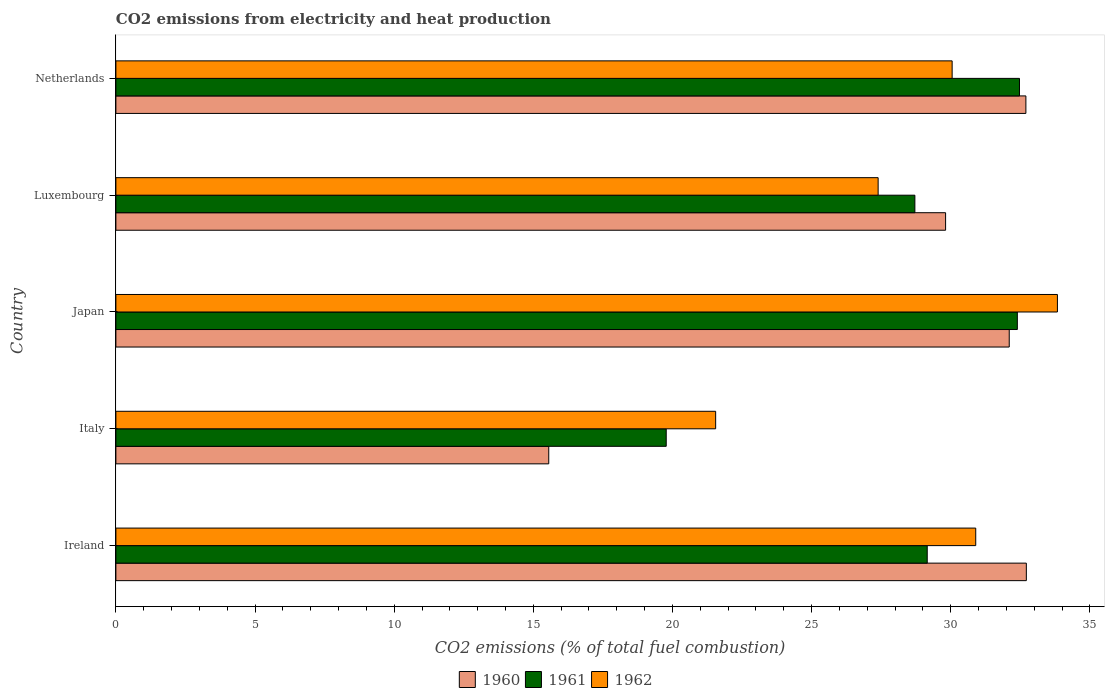How many different coloured bars are there?
Offer a very short reply. 3. Are the number of bars per tick equal to the number of legend labels?
Ensure brevity in your answer.  Yes. Are the number of bars on each tick of the Y-axis equal?
Your response must be concise. Yes. What is the label of the 2nd group of bars from the top?
Your response must be concise. Luxembourg. What is the amount of CO2 emitted in 1960 in Italy?
Offer a terse response. 15.55. Across all countries, what is the maximum amount of CO2 emitted in 1960?
Provide a succinct answer. 32.72. Across all countries, what is the minimum amount of CO2 emitted in 1961?
Offer a very short reply. 19.78. What is the total amount of CO2 emitted in 1961 in the graph?
Your answer should be compact. 142.5. What is the difference between the amount of CO2 emitted in 1962 in Ireland and that in Luxembourg?
Your response must be concise. 3.51. What is the difference between the amount of CO2 emitted in 1960 in Netherlands and the amount of CO2 emitted in 1961 in Ireland?
Keep it short and to the point. 3.55. What is the average amount of CO2 emitted in 1961 per country?
Provide a succinct answer. 28.5. What is the difference between the amount of CO2 emitted in 1962 and amount of CO2 emitted in 1960 in Netherlands?
Provide a short and direct response. -2.65. In how many countries, is the amount of CO2 emitted in 1961 greater than 2 %?
Provide a succinct answer. 5. What is the ratio of the amount of CO2 emitted in 1962 in Ireland to that in Luxembourg?
Ensure brevity in your answer.  1.13. What is the difference between the highest and the second highest amount of CO2 emitted in 1960?
Your answer should be compact. 0.02. What is the difference between the highest and the lowest amount of CO2 emitted in 1962?
Your answer should be compact. 12.28. In how many countries, is the amount of CO2 emitted in 1960 greater than the average amount of CO2 emitted in 1960 taken over all countries?
Your answer should be compact. 4. What does the 3rd bar from the bottom in Italy represents?
Your answer should be compact. 1962. Is it the case that in every country, the sum of the amount of CO2 emitted in 1962 and amount of CO2 emitted in 1960 is greater than the amount of CO2 emitted in 1961?
Give a very brief answer. Yes. How many countries are there in the graph?
Keep it short and to the point. 5. What is the difference between two consecutive major ticks on the X-axis?
Your answer should be very brief. 5. Are the values on the major ticks of X-axis written in scientific E-notation?
Your answer should be very brief. No. Does the graph contain any zero values?
Ensure brevity in your answer.  No. Where does the legend appear in the graph?
Your answer should be compact. Bottom center. How are the legend labels stacked?
Your answer should be very brief. Horizontal. What is the title of the graph?
Ensure brevity in your answer.  CO2 emissions from electricity and heat production. What is the label or title of the X-axis?
Provide a short and direct response. CO2 emissions (% of total fuel combustion). What is the CO2 emissions (% of total fuel combustion) of 1960 in Ireland?
Keep it short and to the point. 32.72. What is the CO2 emissions (% of total fuel combustion) in 1961 in Ireland?
Your response must be concise. 29.15. What is the CO2 emissions (% of total fuel combustion) of 1962 in Ireland?
Provide a short and direct response. 30.9. What is the CO2 emissions (% of total fuel combustion) in 1960 in Italy?
Your answer should be very brief. 15.55. What is the CO2 emissions (% of total fuel combustion) of 1961 in Italy?
Your response must be concise. 19.78. What is the CO2 emissions (% of total fuel combustion) in 1962 in Italy?
Give a very brief answer. 21.55. What is the CO2 emissions (% of total fuel combustion) of 1960 in Japan?
Give a very brief answer. 32.1. What is the CO2 emissions (% of total fuel combustion) of 1961 in Japan?
Keep it short and to the point. 32.39. What is the CO2 emissions (% of total fuel combustion) of 1962 in Japan?
Keep it short and to the point. 33.83. What is the CO2 emissions (% of total fuel combustion) of 1960 in Luxembourg?
Your answer should be compact. 29.81. What is the CO2 emissions (% of total fuel combustion) in 1961 in Luxembourg?
Make the answer very short. 28.71. What is the CO2 emissions (% of total fuel combustion) in 1962 in Luxembourg?
Offer a terse response. 27.39. What is the CO2 emissions (% of total fuel combustion) in 1960 in Netherlands?
Your answer should be very brief. 32.7. What is the CO2 emissions (% of total fuel combustion) in 1961 in Netherlands?
Keep it short and to the point. 32.47. What is the CO2 emissions (% of total fuel combustion) in 1962 in Netherlands?
Your answer should be very brief. 30.05. Across all countries, what is the maximum CO2 emissions (% of total fuel combustion) of 1960?
Keep it short and to the point. 32.72. Across all countries, what is the maximum CO2 emissions (% of total fuel combustion) in 1961?
Provide a succinct answer. 32.47. Across all countries, what is the maximum CO2 emissions (% of total fuel combustion) of 1962?
Offer a very short reply. 33.83. Across all countries, what is the minimum CO2 emissions (% of total fuel combustion) in 1960?
Keep it short and to the point. 15.55. Across all countries, what is the minimum CO2 emissions (% of total fuel combustion) in 1961?
Offer a very short reply. 19.78. Across all countries, what is the minimum CO2 emissions (% of total fuel combustion) in 1962?
Keep it short and to the point. 21.55. What is the total CO2 emissions (% of total fuel combustion) in 1960 in the graph?
Provide a short and direct response. 142.89. What is the total CO2 emissions (% of total fuel combustion) in 1961 in the graph?
Your answer should be compact. 142.5. What is the total CO2 emissions (% of total fuel combustion) of 1962 in the graph?
Provide a short and direct response. 143.72. What is the difference between the CO2 emissions (% of total fuel combustion) in 1960 in Ireland and that in Italy?
Your answer should be very brief. 17.16. What is the difference between the CO2 emissions (% of total fuel combustion) of 1961 in Ireland and that in Italy?
Ensure brevity in your answer.  9.38. What is the difference between the CO2 emissions (% of total fuel combustion) in 1962 in Ireland and that in Italy?
Offer a very short reply. 9.35. What is the difference between the CO2 emissions (% of total fuel combustion) in 1960 in Ireland and that in Japan?
Ensure brevity in your answer.  0.61. What is the difference between the CO2 emissions (% of total fuel combustion) of 1961 in Ireland and that in Japan?
Keep it short and to the point. -3.24. What is the difference between the CO2 emissions (% of total fuel combustion) in 1962 in Ireland and that in Japan?
Make the answer very short. -2.94. What is the difference between the CO2 emissions (% of total fuel combustion) of 1960 in Ireland and that in Luxembourg?
Make the answer very short. 2.9. What is the difference between the CO2 emissions (% of total fuel combustion) in 1961 in Ireland and that in Luxembourg?
Make the answer very short. 0.44. What is the difference between the CO2 emissions (% of total fuel combustion) of 1962 in Ireland and that in Luxembourg?
Your answer should be compact. 3.51. What is the difference between the CO2 emissions (% of total fuel combustion) of 1960 in Ireland and that in Netherlands?
Offer a terse response. 0.02. What is the difference between the CO2 emissions (% of total fuel combustion) in 1961 in Ireland and that in Netherlands?
Your answer should be very brief. -3.31. What is the difference between the CO2 emissions (% of total fuel combustion) of 1962 in Ireland and that in Netherlands?
Your response must be concise. 0.85. What is the difference between the CO2 emissions (% of total fuel combustion) in 1960 in Italy and that in Japan?
Offer a very short reply. -16.55. What is the difference between the CO2 emissions (% of total fuel combustion) of 1961 in Italy and that in Japan?
Your answer should be compact. -12.62. What is the difference between the CO2 emissions (% of total fuel combustion) of 1962 in Italy and that in Japan?
Give a very brief answer. -12.28. What is the difference between the CO2 emissions (% of total fuel combustion) in 1960 in Italy and that in Luxembourg?
Offer a terse response. -14.26. What is the difference between the CO2 emissions (% of total fuel combustion) of 1961 in Italy and that in Luxembourg?
Your answer should be very brief. -8.93. What is the difference between the CO2 emissions (% of total fuel combustion) of 1962 in Italy and that in Luxembourg?
Provide a short and direct response. -5.84. What is the difference between the CO2 emissions (% of total fuel combustion) in 1960 in Italy and that in Netherlands?
Your answer should be very brief. -17.15. What is the difference between the CO2 emissions (% of total fuel combustion) in 1961 in Italy and that in Netherlands?
Give a very brief answer. -12.69. What is the difference between the CO2 emissions (% of total fuel combustion) of 1962 in Italy and that in Netherlands?
Provide a short and direct response. -8.5. What is the difference between the CO2 emissions (% of total fuel combustion) of 1960 in Japan and that in Luxembourg?
Provide a succinct answer. 2.29. What is the difference between the CO2 emissions (% of total fuel combustion) in 1961 in Japan and that in Luxembourg?
Provide a succinct answer. 3.68. What is the difference between the CO2 emissions (% of total fuel combustion) in 1962 in Japan and that in Luxembourg?
Offer a very short reply. 6.44. What is the difference between the CO2 emissions (% of total fuel combustion) of 1960 in Japan and that in Netherlands?
Offer a very short reply. -0.6. What is the difference between the CO2 emissions (% of total fuel combustion) in 1961 in Japan and that in Netherlands?
Your answer should be very brief. -0.08. What is the difference between the CO2 emissions (% of total fuel combustion) in 1962 in Japan and that in Netherlands?
Your response must be concise. 3.78. What is the difference between the CO2 emissions (% of total fuel combustion) in 1960 in Luxembourg and that in Netherlands?
Ensure brevity in your answer.  -2.89. What is the difference between the CO2 emissions (% of total fuel combustion) of 1961 in Luxembourg and that in Netherlands?
Your answer should be compact. -3.76. What is the difference between the CO2 emissions (% of total fuel combustion) in 1962 in Luxembourg and that in Netherlands?
Offer a terse response. -2.66. What is the difference between the CO2 emissions (% of total fuel combustion) of 1960 in Ireland and the CO2 emissions (% of total fuel combustion) of 1961 in Italy?
Your response must be concise. 12.94. What is the difference between the CO2 emissions (% of total fuel combustion) of 1960 in Ireland and the CO2 emissions (% of total fuel combustion) of 1962 in Italy?
Provide a succinct answer. 11.16. What is the difference between the CO2 emissions (% of total fuel combustion) of 1961 in Ireland and the CO2 emissions (% of total fuel combustion) of 1962 in Italy?
Your response must be concise. 7.6. What is the difference between the CO2 emissions (% of total fuel combustion) in 1960 in Ireland and the CO2 emissions (% of total fuel combustion) in 1961 in Japan?
Make the answer very short. 0.32. What is the difference between the CO2 emissions (% of total fuel combustion) of 1960 in Ireland and the CO2 emissions (% of total fuel combustion) of 1962 in Japan?
Keep it short and to the point. -1.12. What is the difference between the CO2 emissions (% of total fuel combustion) of 1961 in Ireland and the CO2 emissions (% of total fuel combustion) of 1962 in Japan?
Give a very brief answer. -4.68. What is the difference between the CO2 emissions (% of total fuel combustion) in 1960 in Ireland and the CO2 emissions (% of total fuel combustion) in 1961 in Luxembourg?
Provide a short and direct response. 4.01. What is the difference between the CO2 emissions (% of total fuel combustion) in 1960 in Ireland and the CO2 emissions (% of total fuel combustion) in 1962 in Luxembourg?
Give a very brief answer. 5.33. What is the difference between the CO2 emissions (% of total fuel combustion) of 1961 in Ireland and the CO2 emissions (% of total fuel combustion) of 1962 in Luxembourg?
Make the answer very short. 1.76. What is the difference between the CO2 emissions (% of total fuel combustion) of 1960 in Ireland and the CO2 emissions (% of total fuel combustion) of 1961 in Netherlands?
Provide a succinct answer. 0.25. What is the difference between the CO2 emissions (% of total fuel combustion) of 1960 in Ireland and the CO2 emissions (% of total fuel combustion) of 1962 in Netherlands?
Your answer should be very brief. 2.67. What is the difference between the CO2 emissions (% of total fuel combustion) in 1961 in Ireland and the CO2 emissions (% of total fuel combustion) in 1962 in Netherlands?
Ensure brevity in your answer.  -0.9. What is the difference between the CO2 emissions (% of total fuel combustion) of 1960 in Italy and the CO2 emissions (% of total fuel combustion) of 1961 in Japan?
Your answer should be very brief. -16.84. What is the difference between the CO2 emissions (% of total fuel combustion) of 1960 in Italy and the CO2 emissions (% of total fuel combustion) of 1962 in Japan?
Offer a very short reply. -18.28. What is the difference between the CO2 emissions (% of total fuel combustion) of 1961 in Italy and the CO2 emissions (% of total fuel combustion) of 1962 in Japan?
Offer a terse response. -14.06. What is the difference between the CO2 emissions (% of total fuel combustion) in 1960 in Italy and the CO2 emissions (% of total fuel combustion) in 1961 in Luxembourg?
Provide a short and direct response. -13.16. What is the difference between the CO2 emissions (% of total fuel combustion) in 1960 in Italy and the CO2 emissions (% of total fuel combustion) in 1962 in Luxembourg?
Provide a succinct answer. -11.84. What is the difference between the CO2 emissions (% of total fuel combustion) of 1961 in Italy and the CO2 emissions (% of total fuel combustion) of 1962 in Luxembourg?
Keep it short and to the point. -7.62. What is the difference between the CO2 emissions (% of total fuel combustion) of 1960 in Italy and the CO2 emissions (% of total fuel combustion) of 1961 in Netherlands?
Provide a short and direct response. -16.92. What is the difference between the CO2 emissions (% of total fuel combustion) of 1960 in Italy and the CO2 emissions (% of total fuel combustion) of 1962 in Netherlands?
Provide a succinct answer. -14.5. What is the difference between the CO2 emissions (% of total fuel combustion) in 1961 in Italy and the CO2 emissions (% of total fuel combustion) in 1962 in Netherlands?
Your answer should be very brief. -10.27. What is the difference between the CO2 emissions (% of total fuel combustion) of 1960 in Japan and the CO2 emissions (% of total fuel combustion) of 1961 in Luxembourg?
Offer a terse response. 3.39. What is the difference between the CO2 emissions (% of total fuel combustion) in 1960 in Japan and the CO2 emissions (% of total fuel combustion) in 1962 in Luxembourg?
Your answer should be compact. 4.71. What is the difference between the CO2 emissions (% of total fuel combustion) of 1961 in Japan and the CO2 emissions (% of total fuel combustion) of 1962 in Luxembourg?
Make the answer very short. 5. What is the difference between the CO2 emissions (% of total fuel combustion) in 1960 in Japan and the CO2 emissions (% of total fuel combustion) in 1961 in Netherlands?
Ensure brevity in your answer.  -0.37. What is the difference between the CO2 emissions (% of total fuel combustion) in 1960 in Japan and the CO2 emissions (% of total fuel combustion) in 1962 in Netherlands?
Offer a very short reply. 2.05. What is the difference between the CO2 emissions (% of total fuel combustion) of 1961 in Japan and the CO2 emissions (% of total fuel combustion) of 1962 in Netherlands?
Your answer should be very brief. 2.34. What is the difference between the CO2 emissions (% of total fuel combustion) in 1960 in Luxembourg and the CO2 emissions (% of total fuel combustion) in 1961 in Netherlands?
Ensure brevity in your answer.  -2.66. What is the difference between the CO2 emissions (% of total fuel combustion) in 1960 in Luxembourg and the CO2 emissions (% of total fuel combustion) in 1962 in Netherlands?
Make the answer very short. -0.24. What is the difference between the CO2 emissions (% of total fuel combustion) in 1961 in Luxembourg and the CO2 emissions (% of total fuel combustion) in 1962 in Netherlands?
Offer a terse response. -1.34. What is the average CO2 emissions (% of total fuel combustion) of 1960 per country?
Your response must be concise. 28.58. What is the average CO2 emissions (% of total fuel combustion) of 1961 per country?
Ensure brevity in your answer.  28.5. What is the average CO2 emissions (% of total fuel combustion) in 1962 per country?
Make the answer very short. 28.74. What is the difference between the CO2 emissions (% of total fuel combustion) of 1960 and CO2 emissions (% of total fuel combustion) of 1961 in Ireland?
Provide a succinct answer. 3.56. What is the difference between the CO2 emissions (% of total fuel combustion) of 1960 and CO2 emissions (% of total fuel combustion) of 1962 in Ireland?
Ensure brevity in your answer.  1.82. What is the difference between the CO2 emissions (% of total fuel combustion) of 1961 and CO2 emissions (% of total fuel combustion) of 1962 in Ireland?
Provide a succinct answer. -1.74. What is the difference between the CO2 emissions (% of total fuel combustion) of 1960 and CO2 emissions (% of total fuel combustion) of 1961 in Italy?
Ensure brevity in your answer.  -4.22. What is the difference between the CO2 emissions (% of total fuel combustion) of 1960 and CO2 emissions (% of total fuel combustion) of 1962 in Italy?
Offer a very short reply. -6. What is the difference between the CO2 emissions (% of total fuel combustion) of 1961 and CO2 emissions (% of total fuel combustion) of 1962 in Italy?
Make the answer very short. -1.78. What is the difference between the CO2 emissions (% of total fuel combustion) in 1960 and CO2 emissions (% of total fuel combustion) in 1961 in Japan?
Offer a very short reply. -0.29. What is the difference between the CO2 emissions (% of total fuel combustion) of 1960 and CO2 emissions (% of total fuel combustion) of 1962 in Japan?
Your answer should be compact. -1.73. What is the difference between the CO2 emissions (% of total fuel combustion) in 1961 and CO2 emissions (% of total fuel combustion) in 1962 in Japan?
Offer a very short reply. -1.44. What is the difference between the CO2 emissions (% of total fuel combustion) of 1960 and CO2 emissions (% of total fuel combustion) of 1961 in Luxembourg?
Your answer should be compact. 1.1. What is the difference between the CO2 emissions (% of total fuel combustion) in 1960 and CO2 emissions (% of total fuel combustion) in 1962 in Luxembourg?
Your answer should be very brief. 2.42. What is the difference between the CO2 emissions (% of total fuel combustion) of 1961 and CO2 emissions (% of total fuel combustion) of 1962 in Luxembourg?
Offer a very short reply. 1.32. What is the difference between the CO2 emissions (% of total fuel combustion) of 1960 and CO2 emissions (% of total fuel combustion) of 1961 in Netherlands?
Make the answer very short. 0.23. What is the difference between the CO2 emissions (% of total fuel combustion) of 1960 and CO2 emissions (% of total fuel combustion) of 1962 in Netherlands?
Make the answer very short. 2.65. What is the difference between the CO2 emissions (% of total fuel combustion) in 1961 and CO2 emissions (% of total fuel combustion) in 1962 in Netherlands?
Provide a succinct answer. 2.42. What is the ratio of the CO2 emissions (% of total fuel combustion) of 1960 in Ireland to that in Italy?
Your answer should be very brief. 2.1. What is the ratio of the CO2 emissions (% of total fuel combustion) of 1961 in Ireland to that in Italy?
Keep it short and to the point. 1.47. What is the ratio of the CO2 emissions (% of total fuel combustion) of 1962 in Ireland to that in Italy?
Your answer should be very brief. 1.43. What is the ratio of the CO2 emissions (% of total fuel combustion) in 1960 in Ireland to that in Japan?
Give a very brief answer. 1.02. What is the ratio of the CO2 emissions (% of total fuel combustion) of 1961 in Ireland to that in Japan?
Your answer should be very brief. 0.9. What is the ratio of the CO2 emissions (% of total fuel combustion) in 1962 in Ireland to that in Japan?
Your response must be concise. 0.91. What is the ratio of the CO2 emissions (% of total fuel combustion) of 1960 in Ireland to that in Luxembourg?
Ensure brevity in your answer.  1.1. What is the ratio of the CO2 emissions (% of total fuel combustion) in 1961 in Ireland to that in Luxembourg?
Your answer should be compact. 1.02. What is the ratio of the CO2 emissions (% of total fuel combustion) in 1962 in Ireland to that in Luxembourg?
Provide a short and direct response. 1.13. What is the ratio of the CO2 emissions (% of total fuel combustion) of 1960 in Ireland to that in Netherlands?
Give a very brief answer. 1. What is the ratio of the CO2 emissions (% of total fuel combustion) of 1961 in Ireland to that in Netherlands?
Provide a succinct answer. 0.9. What is the ratio of the CO2 emissions (% of total fuel combustion) of 1962 in Ireland to that in Netherlands?
Ensure brevity in your answer.  1.03. What is the ratio of the CO2 emissions (% of total fuel combustion) of 1960 in Italy to that in Japan?
Ensure brevity in your answer.  0.48. What is the ratio of the CO2 emissions (% of total fuel combustion) of 1961 in Italy to that in Japan?
Your answer should be compact. 0.61. What is the ratio of the CO2 emissions (% of total fuel combustion) of 1962 in Italy to that in Japan?
Provide a short and direct response. 0.64. What is the ratio of the CO2 emissions (% of total fuel combustion) in 1960 in Italy to that in Luxembourg?
Your answer should be compact. 0.52. What is the ratio of the CO2 emissions (% of total fuel combustion) in 1961 in Italy to that in Luxembourg?
Offer a terse response. 0.69. What is the ratio of the CO2 emissions (% of total fuel combustion) of 1962 in Italy to that in Luxembourg?
Give a very brief answer. 0.79. What is the ratio of the CO2 emissions (% of total fuel combustion) in 1960 in Italy to that in Netherlands?
Provide a succinct answer. 0.48. What is the ratio of the CO2 emissions (% of total fuel combustion) in 1961 in Italy to that in Netherlands?
Offer a terse response. 0.61. What is the ratio of the CO2 emissions (% of total fuel combustion) in 1962 in Italy to that in Netherlands?
Your response must be concise. 0.72. What is the ratio of the CO2 emissions (% of total fuel combustion) in 1960 in Japan to that in Luxembourg?
Provide a succinct answer. 1.08. What is the ratio of the CO2 emissions (% of total fuel combustion) in 1961 in Japan to that in Luxembourg?
Give a very brief answer. 1.13. What is the ratio of the CO2 emissions (% of total fuel combustion) in 1962 in Japan to that in Luxembourg?
Keep it short and to the point. 1.24. What is the ratio of the CO2 emissions (% of total fuel combustion) of 1960 in Japan to that in Netherlands?
Provide a succinct answer. 0.98. What is the ratio of the CO2 emissions (% of total fuel combustion) in 1962 in Japan to that in Netherlands?
Your answer should be compact. 1.13. What is the ratio of the CO2 emissions (% of total fuel combustion) in 1960 in Luxembourg to that in Netherlands?
Give a very brief answer. 0.91. What is the ratio of the CO2 emissions (% of total fuel combustion) of 1961 in Luxembourg to that in Netherlands?
Your answer should be very brief. 0.88. What is the ratio of the CO2 emissions (% of total fuel combustion) in 1962 in Luxembourg to that in Netherlands?
Provide a short and direct response. 0.91. What is the difference between the highest and the second highest CO2 emissions (% of total fuel combustion) of 1960?
Your response must be concise. 0.02. What is the difference between the highest and the second highest CO2 emissions (% of total fuel combustion) of 1961?
Give a very brief answer. 0.08. What is the difference between the highest and the second highest CO2 emissions (% of total fuel combustion) of 1962?
Your answer should be compact. 2.94. What is the difference between the highest and the lowest CO2 emissions (% of total fuel combustion) of 1960?
Offer a terse response. 17.16. What is the difference between the highest and the lowest CO2 emissions (% of total fuel combustion) of 1961?
Your answer should be very brief. 12.69. What is the difference between the highest and the lowest CO2 emissions (% of total fuel combustion) in 1962?
Ensure brevity in your answer.  12.28. 